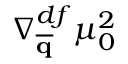Convert formula to latex. <formula><loc_0><loc_0><loc_500><loc_500>\nabla _ { \overline { q } } ^ { d f } \mu _ { 0 } ^ { 2 }</formula> 